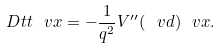Convert formula to latex. <formula><loc_0><loc_0><loc_500><loc_500>\ D t t \ v x = - \frac { 1 } { q ^ { 2 } } V ^ { \prime \prime } ( \ v d ) \ v x .</formula> 